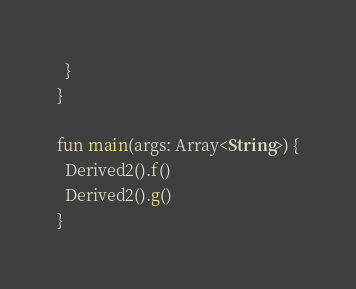<code> <loc_0><loc_0><loc_500><loc_500><_Kotlin_>  }
}

fun main(args: Array<String>) {
  Derived2().f()
  Derived2().g()
}
</code> 